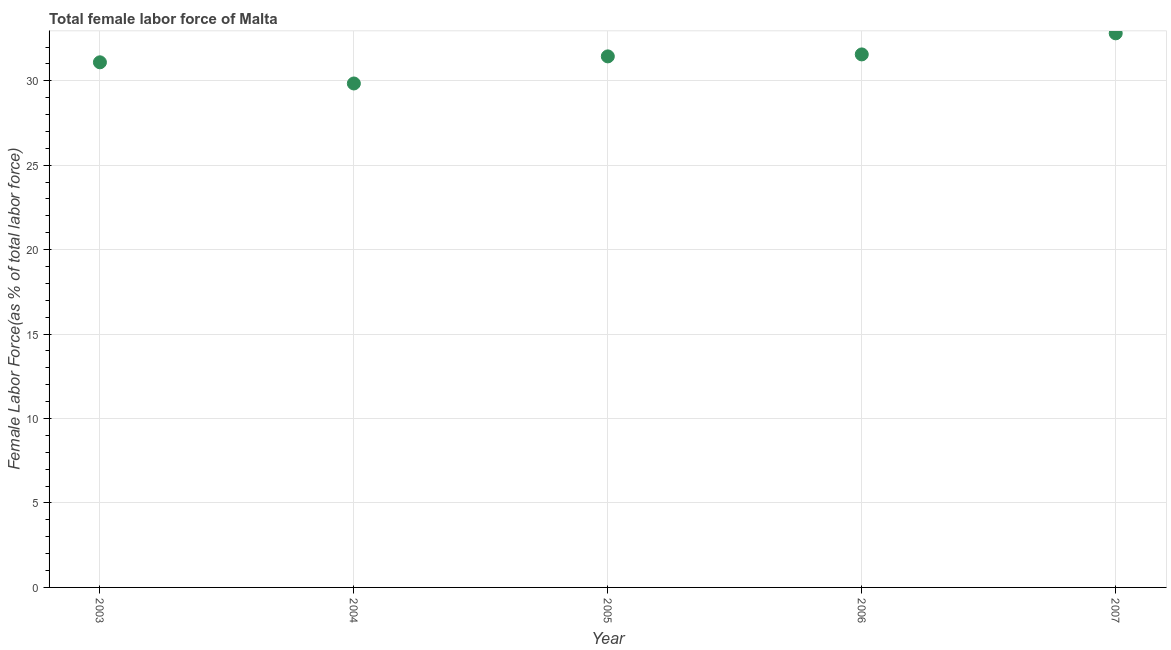What is the total female labor force in 2007?
Your response must be concise. 32.81. Across all years, what is the maximum total female labor force?
Your answer should be very brief. 32.81. Across all years, what is the minimum total female labor force?
Offer a very short reply. 29.84. In which year was the total female labor force minimum?
Provide a short and direct response. 2004. What is the sum of the total female labor force?
Your response must be concise. 156.75. What is the difference between the total female labor force in 2003 and 2005?
Your answer should be compact. -0.35. What is the average total female labor force per year?
Give a very brief answer. 31.35. What is the median total female labor force?
Offer a very short reply. 31.44. In how many years, is the total female labor force greater than 12 %?
Make the answer very short. 5. What is the ratio of the total female labor force in 2003 to that in 2007?
Your response must be concise. 0.95. Is the difference between the total female labor force in 2005 and 2006 greater than the difference between any two years?
Your answer should be very brief. No. What is the difference between the highest and the second highest total female labor force?
Your answer should be very brief. 1.25. Is the sum of the total female labor force in 2005 and 2006 greater than the maximum total female labor force across all years?
Offer a very short reply. Yes. What is the difference between the highest and the lowest total female labor force?
Make the answer very short. 2.97. How many years are there in the graph?
Your response must be concise. 5. What is the difference between two consecutive major ticks on the Y-axis?
Provide a succinct answer. 5. Are the values on the major ticks of Y-axis written in scientific E-notation?
Ensure brevity in your answer.  No. Does the graph contain any zero values?
Your response must be concise. No. What is the title of the graph?
Offer a very short reply. Total female labor force of Malta. What is the label or title of the X-axis?
Your response must be concise. Year. What is the label or title of the Y-axis?
Your answer should be very brief. Female Labor Force(as % of total labor force). What is the Female Labor Force(as % of total labor force) in 2003?
Provide a succinct answer. 31.09. What is the Female Labor Force(as % of total labor force) in 2004?
Your answer should be very brief. 29.84. What is the Female Labor Force(as % of total labor force) in 2005?
Provide a succinct answer. 31.44. What is the Female Labor Force(as % of total labor force) in 2006?
Your response must be concise. 31.56. What is the Female Labor Force(as % of total labor force) in 2007?
Keep it short and to the point. 32.81. What is the difference between the Female Labor Force(as % of total labor force) in 2003 and 2004?
Your answer should be very brief. 1.25. What is the difference between the Female Labor Force(as % of total labor force) in 2003 and 2005?
Keep it short and to the point. -0.35. What is the difference between the Female Labor Force(as % of total labor force) in 2003 and 2006?
Keep it short and to the point. -0.47. What is the difference between the Female Labor Force(as % of total labor force) in 2003 and 2007?
Keep it short and to the point. -1.72. What is the difference between the Female Labor Force(as % of total labor force) in 2004 and 2005?
Offer a very short reply. -1.6. What is the difference between the Female Labor Force(as % of total labor force) in 2004 and 2006?
Ensure brevity in your answer.  -1.72. What is the difference between the Female Labor Force(as % of total labor force) in 2004 and 2007?
Provide a short and direct response. -2.97. What is the difference between the Female Labor Force(as % of total labor force) in 2005 and 2006?
Your answer should be very brief. -0.12. What is the difference between the Female Labor Force(as % of total labor force) in 2005 and 2007?
Your response must be concise. -1.37. What is the difference between the Female Labor Force(as % of total labor force) in 2006 and 2007?
Offer a terse response. -1.25. What is the ratio of the Female Labor Force(as % of total labor force) in 2003 to that in 2004?
Provide a short and direct response. 1.04. What is the ratio of the Female Labor Force(as % of total labor force) in 2003 to that in 2005?
Ensure brevity in your answer.  0.99. What is the ratio of the Female Labor Force(as % of total labor force) in 2003 to that in 2007?
Offer a very short reply. 0.95. What is the ratio of the Female Labor Force(as % of total labor force) in 2004 to that in 2005?
Your answer should be compact. 0.95. What is the ratio of the Female Labor Force(as % of total labor force) in 2004 to that in 2006?
Your response must be concise. 0.94. What is the ratio of the Female Labor Force(as % of total labor force) in 2004 to that in 2007?
Make the answer very short. 0.91. What is the ratio of the Female Labor Force(as % of total labor force) in 2005 to that in 2006?
Keep it short and to the point. 1. What is the ratio of the Female Labor Force(as % of total labor force) in 2005 to that in 2007?
Your response must be concise. 0.96. 